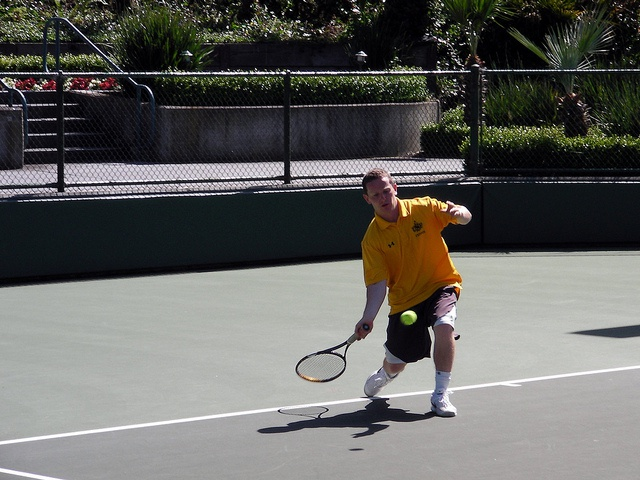Describe the objects in this image and their specific colors. I can see people in gray, maroon, and black tones, tennis racket in gray, darkgray, black, and lightgray tones, and sports ball in gray, green, darkgreen, khaki, and olive tones in this image. 